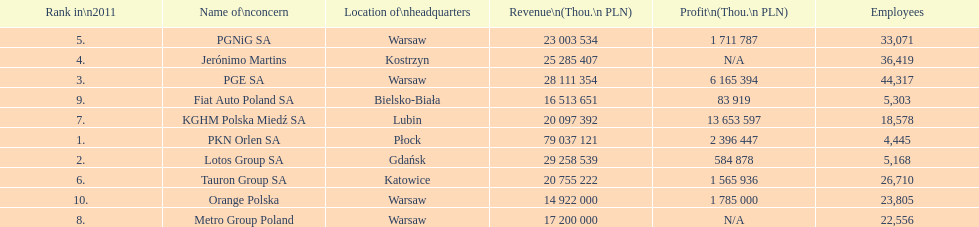What is the number of employees who work for pgnig sa? 33,071. 